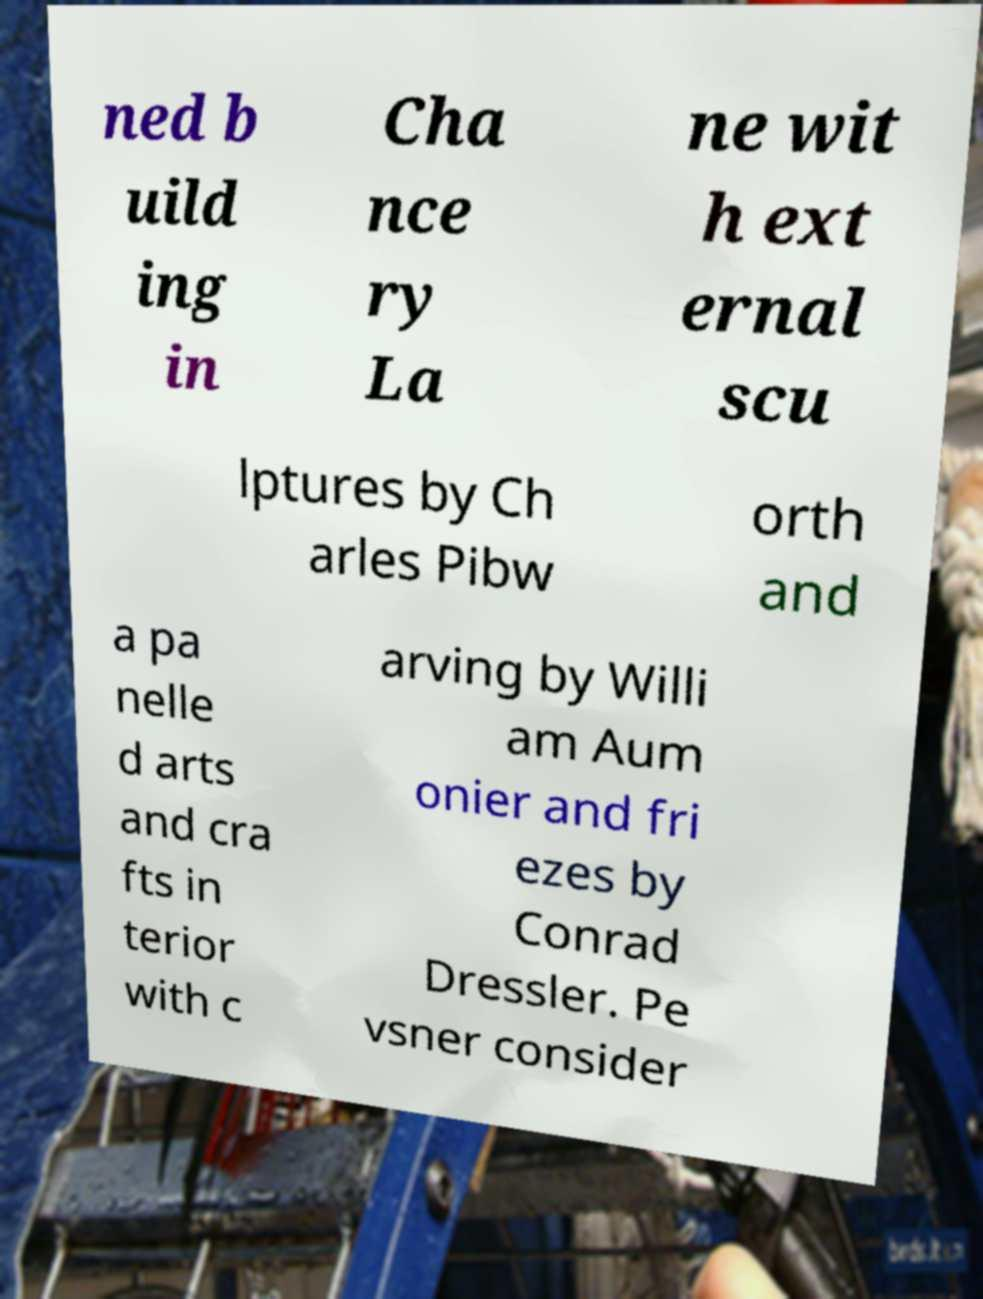For documentation purposes, I need the text within this image transcribed. Could you provide that? ned b uild ing in Cha nce ry La ne wit h ext ernal scu lptures by Ch arles Pibw orth and a pa nelle d arts and cra fts in terior with c arving by Willi am Aum onier and fri ezes by Conrad Dressler. Pe vsner consider 